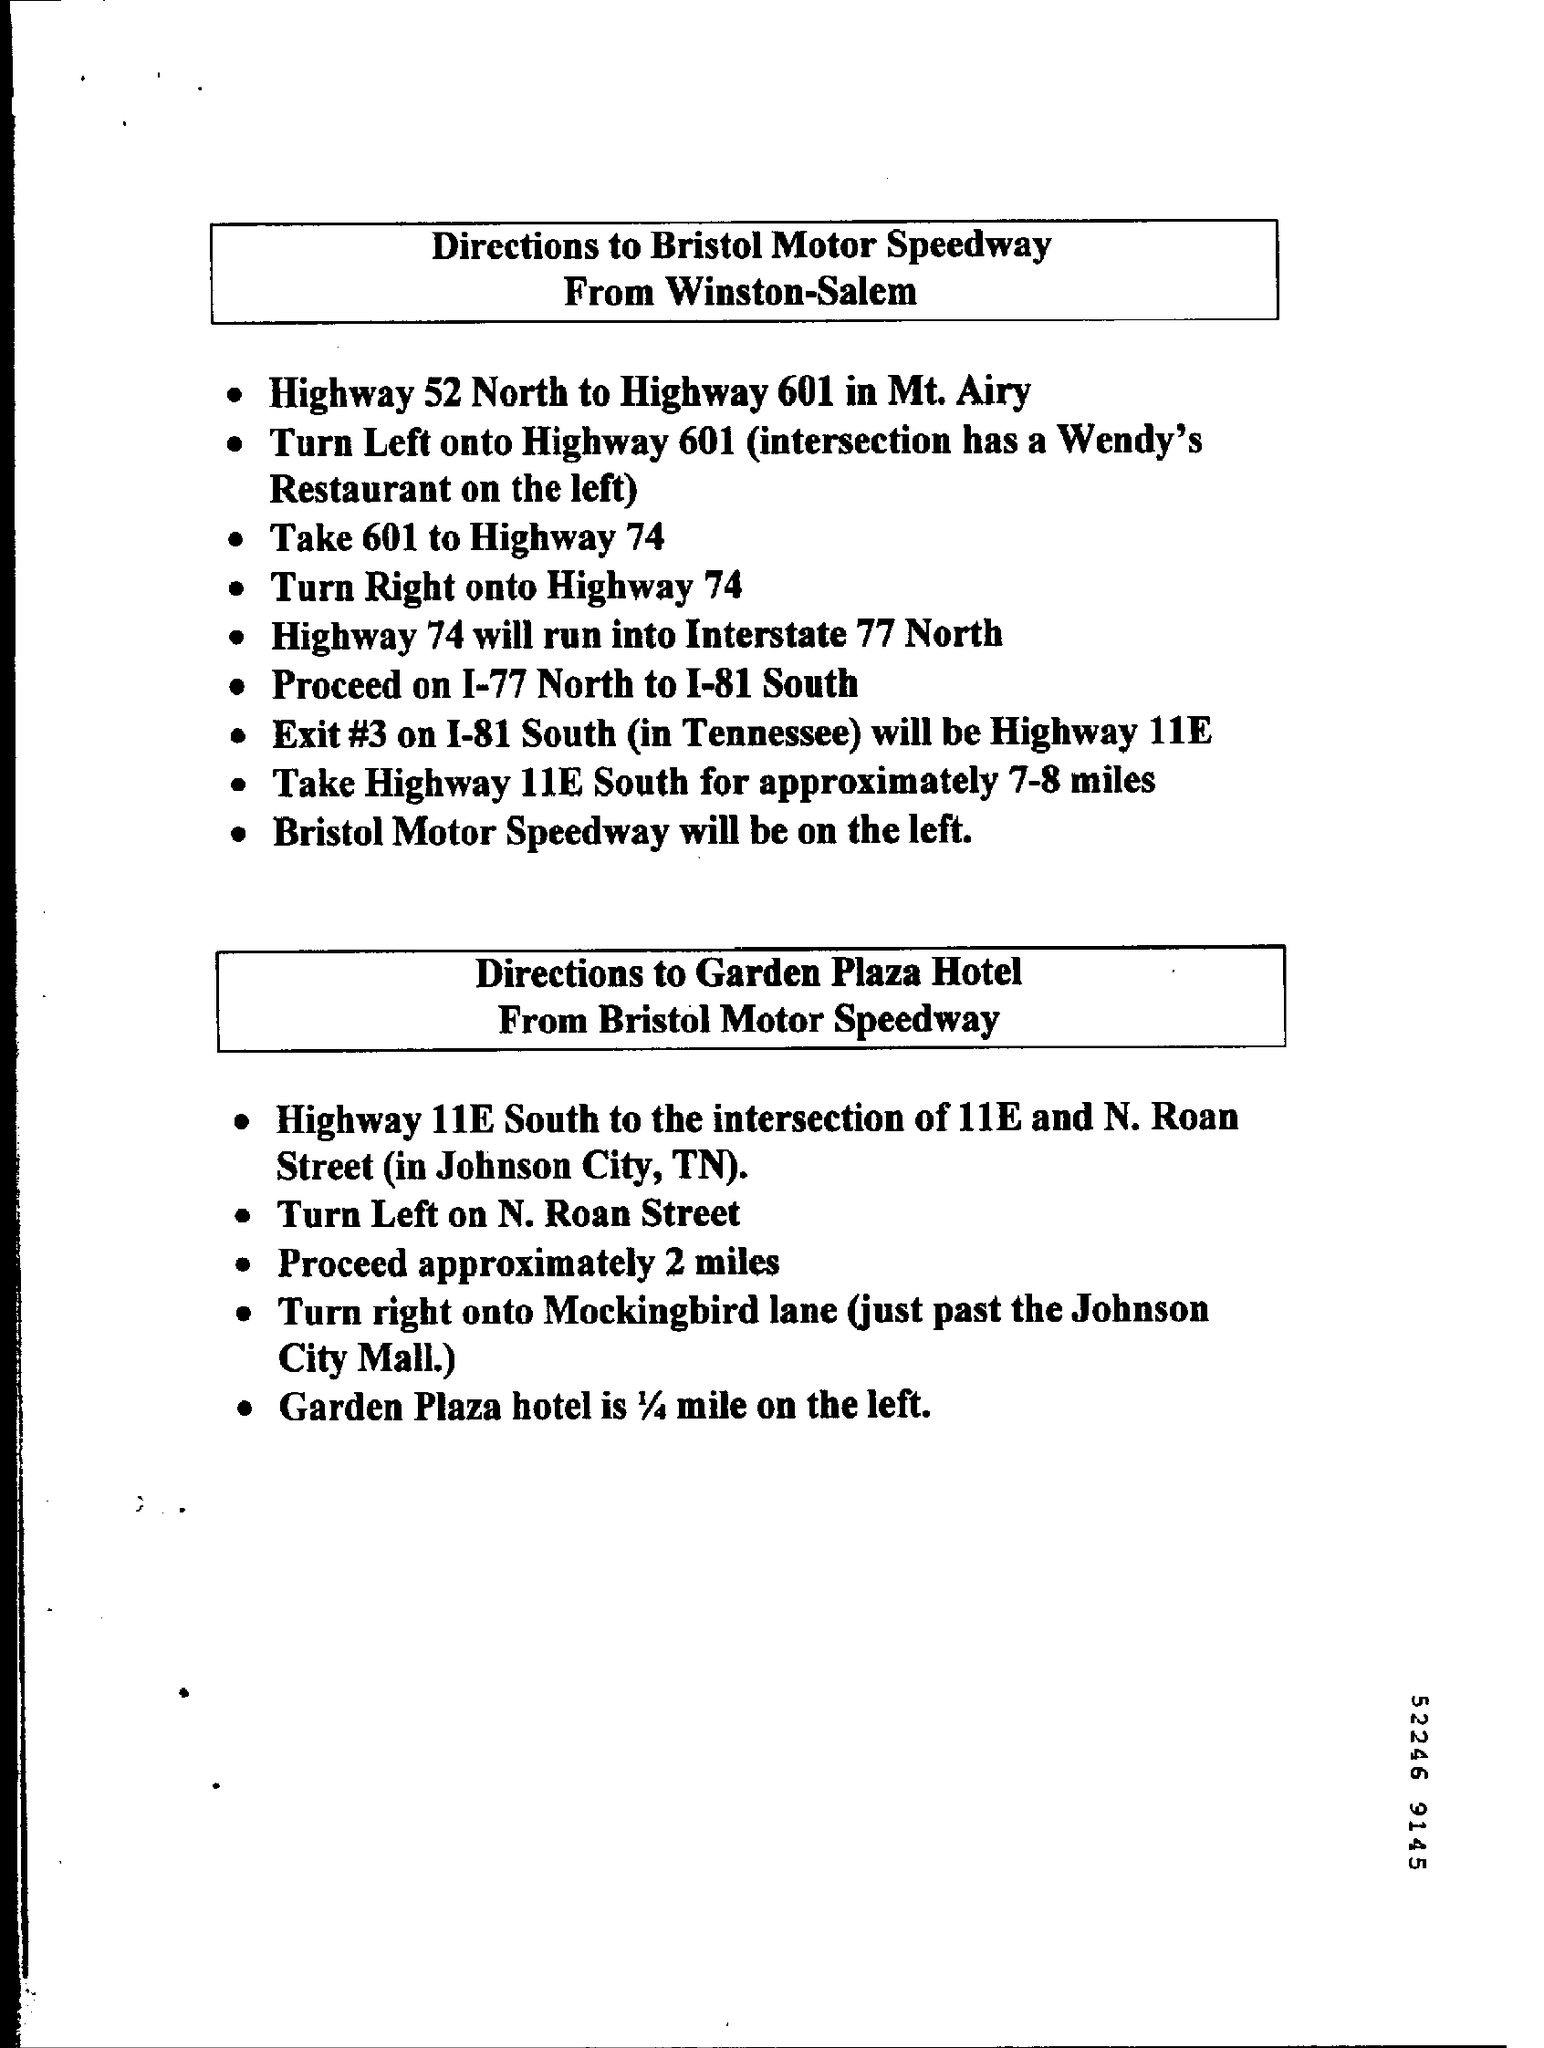Mention a couple of crucial points in this snapshot. The second box contains written instructions that provide directions from Bristol Motor Speedway to the Garden Plaza Hotel. The number at the bottom is 52246. 